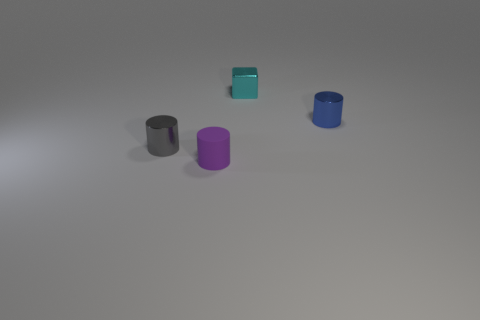Can you tell me what the purpose of these cylindrical objects might be? Their simplistic design and identical shapes suggest they could be a part of a minimalist art installation, or they might serve an educational purpose, perhaps as models to teach about geometric shapes and volume in a classroom setting. 